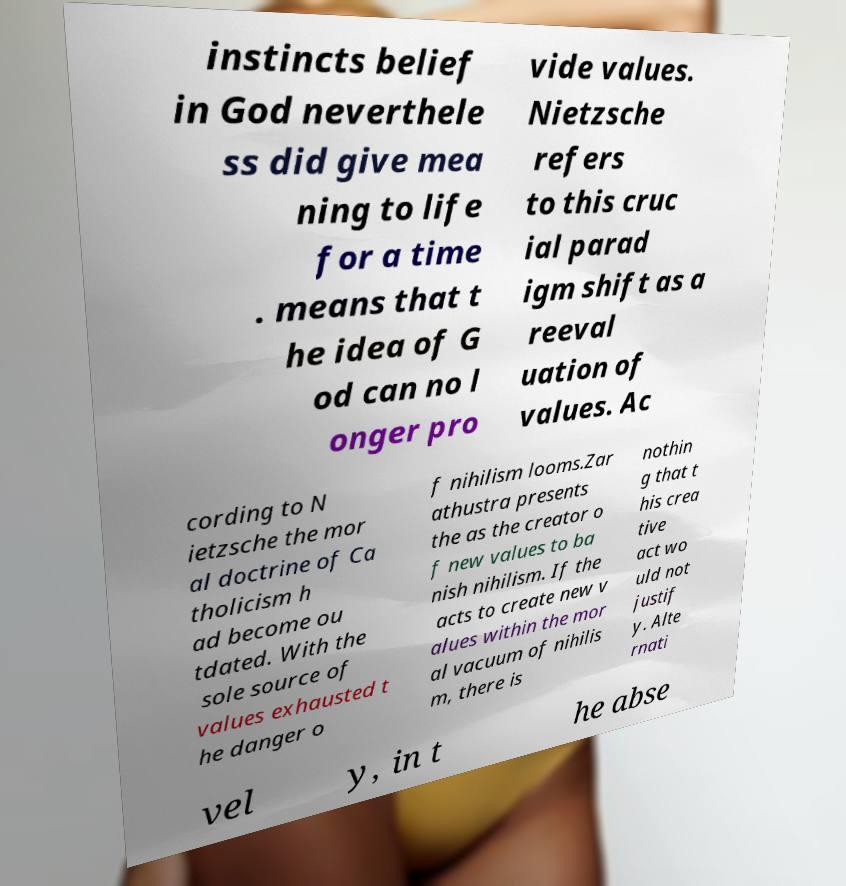For documentation purposes, I need the text within this image transcribed. Could you provide that? instincts belief in God neverthele ss did give mea ning to life for a time . means that t he idea of G od can no l onger pro vide values. Nietzsche refers to this cruc ial parad igm shift as a reeval uation of values. Ac cording to N ietzsche the mor al doctrine of Ca tholicism h ad become ou tdated. With the sole source of values exhausted t he danger o f nihilism looms.Zar athustra presents the as the creator o f new values to ba nish nihilism. If the acts to create new v alues within the mor al vacuum of nihilis m, there is nothin g that t his crea tive act wo uld not justif y. Alte rnati vel y, in t he abse 